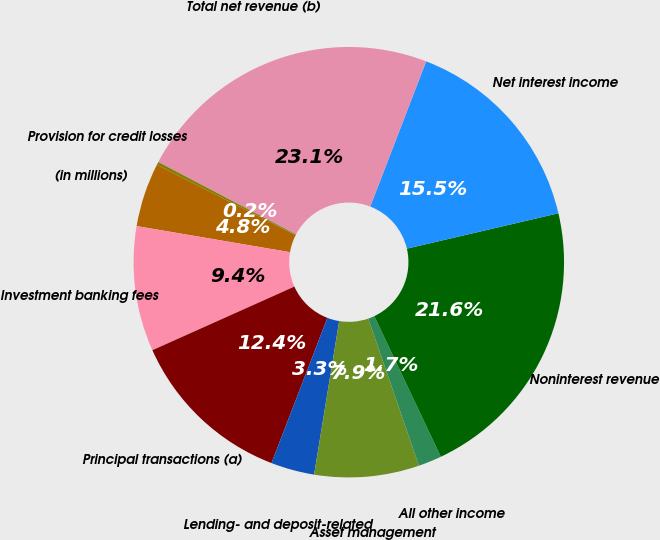<chart> <loc_0><loc_0><loc_500><loc_500><pie_chart><fcel>(in millions)<fcel>Investment banking fees<fcel>Principal transactions (a)<fcel>Lending- and deposit-related<fcel>Asset management<fcel>All other income<fcel>Noninterest revenue<fcel>Net interest income<fcel>Total net revenue (b)<fcel>Provision for credit losses<nl><fcel>4.8%<fcel>9.39%<fcel>12.45%<fcel>3.27%<fcel>7.86%<fcel>1.75%<fcel>21.62%<fcel>15.5%<fcel>23.15%<fcel>0.22%<nl></chart> 